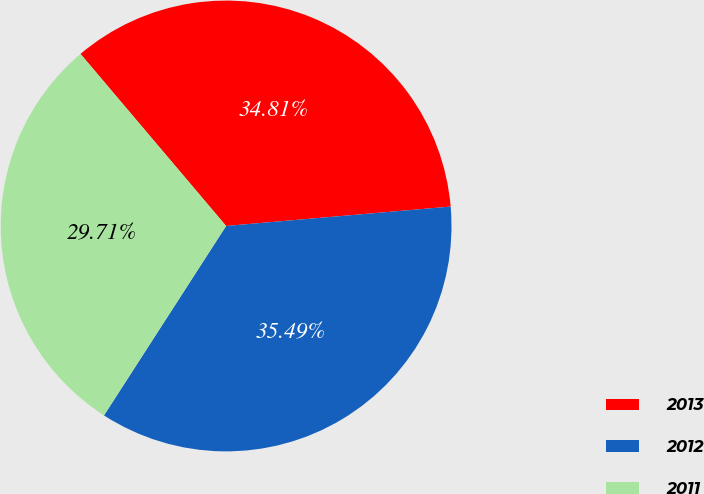<chart> <loc_0><loc_0><loc_500><loc_500><pie_chart><fcel>2013<fcel>2012<fcel>2011<nl><fcel>34.81%<fcel>35.49%<fcel>29.71%<nl></chart> 